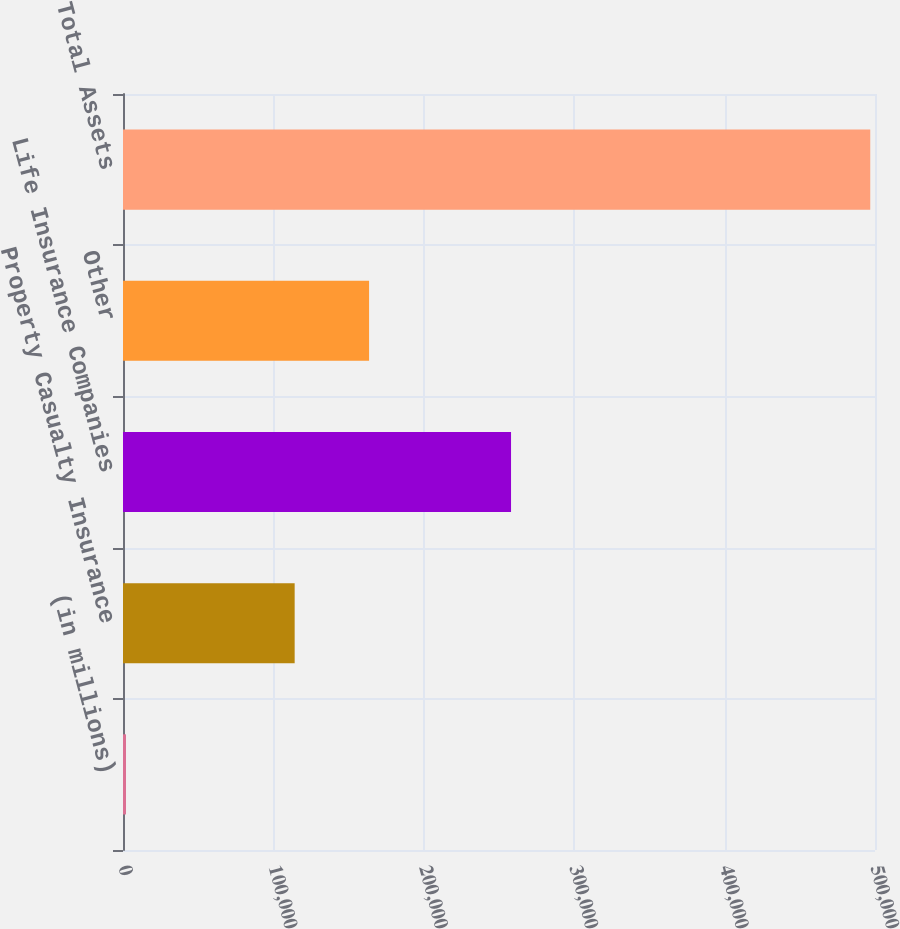Convert chart to OTSL. <chart><loc_0><loc_0><loc_500><loc_500><bar_chart><fcel>(in millions)<fcel>Property Casualty Insurance<fcel>Life Insurance Companies<fcel>Other<fcel>Total Assets<nl><fcel>2015<fcel>114134<fcel>258003<fcel>163617<fcel>496842<nl></chart> 